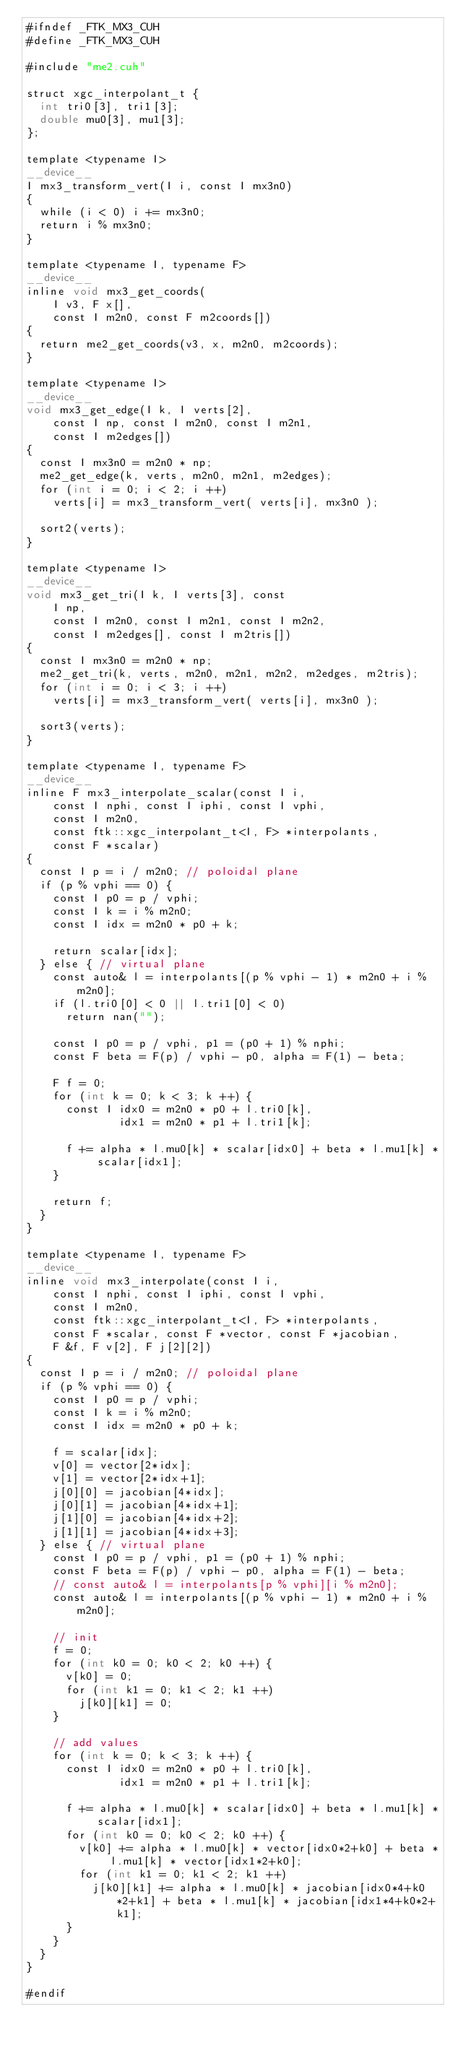Convert code to text. <code><loc_0><loc_0><loc_500><loc_500><_Cuda_>#ifndef _FTK_MX3_CUH
#define _FTK_MX3_CUH

#include "me2.cuh"

struct xgc_interpolant_t {
  int tri0[3], tri1[3];
  double mu0[3], mu1[3];
};

template <typename I>
__device__
I mx3_transform_vert(I i, const I mx3n0)
{
  while (i < 0) i += mx3n0;
  return i % mx3n0;
}

template <typename I, typename F>
__device__
inline void mx3_get_coords(
    I v3, F x[], 
    const I m2n0, const F m2coords[])
{
  return me2_get_coords(v3, x, m2n0, m2coords);
}

template <typename I>
__device__
void mx3_get_edge(I k, I verts[2], 
    const I np, const I m2n0, const I m2n1, 
    const I m2edges[])
{
  const I mx3n0 = m2n0 * np;
  me2_get_edge(k, verts, m2n0, m2n1, m2edges);
  for (int i = 0; i < 2; i ++)
    verts[i] = mx3_transform_vert( verts[i], mx3n0 );

  sort2(verts);
}

template <typename I>
__device__
void mx3_get_tri(I k, I verts[3], const 
    I np, 
    const I m2n0, const I m2n1, const I m2n2, 
    const I m2edges[], const I m2tris[])
{
  const I mx3n0 = m2n0 * np;
  me2_get_tri(k, verts, m2n0, m2n1, m2n2, m2edges, m2tris);
  for (int i = 0; i < 3; i ++) 
    verts[i] = mx3_transform_vert( verts[i], mx3n0 );

  sort3(verts);
}

template <typename I, typename F>
__device__
inline F mx3_interpolate_scalar(const I i,
    const I nphi, const I iphi, const I vphi,
    const I m2n0, 
    const ftk::xgc_interpolant_t<I, F> *interpolants,
    const F *scalar)
{
  const I p = i / m2n0; // poloidal plane
  if (p % vphi == 0) {
    const I p0 = p / vphi;
    const I k = i % m2n0;
    const I idx = m2n0 * p0 + k;

    return scalar[idx];
  } else { // virtual plane
    const auto& l = interpolants[(p % vphi - 1) * m2n0 + i % m2n0];
    if (l.tri0[0] < 0 || l.tri1[0] < 0) 
      return nan("");

    const I p0 = p / vphi, p1 = (p0 + 1) % nphi;
    const F beta = F(p) / vphi - p0, alpha = F(1) - beta;

    F f = 0;
    for (int k = 0; k < 3; k ++) {
      const I idx0 = m2n0 * p0 + l.tri0[k], 
              idx1 = m2n0 * p1 + l.tri1[k];

      f += alpha * l.mu0[k] * scalar[idx0] + beta * l.mu1[k] * scalar[idx1];
    }

    return f;
  }
}

template <typename I, typename F>
__device__
inline void mx3_interpolate(const I i,
    const I nphi, const I iphi, const I vphi,
    const I m2n0, 
    const ftk::xgc_interpolant_t<I, F> *interpolants, 
    const F *scalar, const F *vector, const F *jacobian, 
    F &f, F v[2], F j[2][2])
{
  const I p = i / m2n0; // poloidal plane
  if (p % vphi == 0) {
    const I p0 = p / vphi;
    const I k = i % m2n0;
    const I idx = m2n0 * p0 + k;

    f = scalar[idx];
    v[0] = vector[2*idx];
    v[1] = vector[2*idx+1];
    j[0][0] = jacobian[4*idx];
    j[0][1] = jacobian[4*idx+1];
    j[1][0] = jacobian[4*idx+2];
    j[1][1] = jacobian[4*idx+3];
  } else { // virtual plane
    const I p0 = p / vphi, p1 = (p0 + 1) % nphi;
    const F beta = F(p) / vphi - p0, alpha = F(1) - beta;
    // const auto& l = interpolants[p % vphi][i % m2n0];
    const auto& l = interpolants[(p % vphi - 1) * m2n0 + i % m2n0];

    // init
    f = 0;
    for (int k0 = 0; k0 < 2; k0 ++) {
      v[k0] = 0;
      for (int k1 = 0; k1 < 2; k1 ++) 
        j[k0][k1] = 0;
    }

    // add values
    for (int k = 0; k < 3; k ++) {
      const I idx0 = m2n0 * p0 + l.tri0[k], 
              idx1 = m2n0 * p1 + l.tri1[k];

      f += alpha * l.mu0[k] * scalar[idx0] + beta * l.mu1[k] * scalar[idx1];
      for (int k0 = 0; k0 < 2; k0 ++) {
        v[k0] += alpha * l.mu0[k] * vector[idx0*2+k0] + beta * l.mu1[k] * vector[idx1*2+k0];
        for (int k1 = 0; k1 < 2; k1 ++) 
          j[k0][k1] += alpha * l.mu0[k] * jacobian[idx0*4+k0*2+k1] + beta * l.mu1[k] * jacobian[idx1*4+k0*2+k1];
      }
    }
  }
}

#endif
</code> 